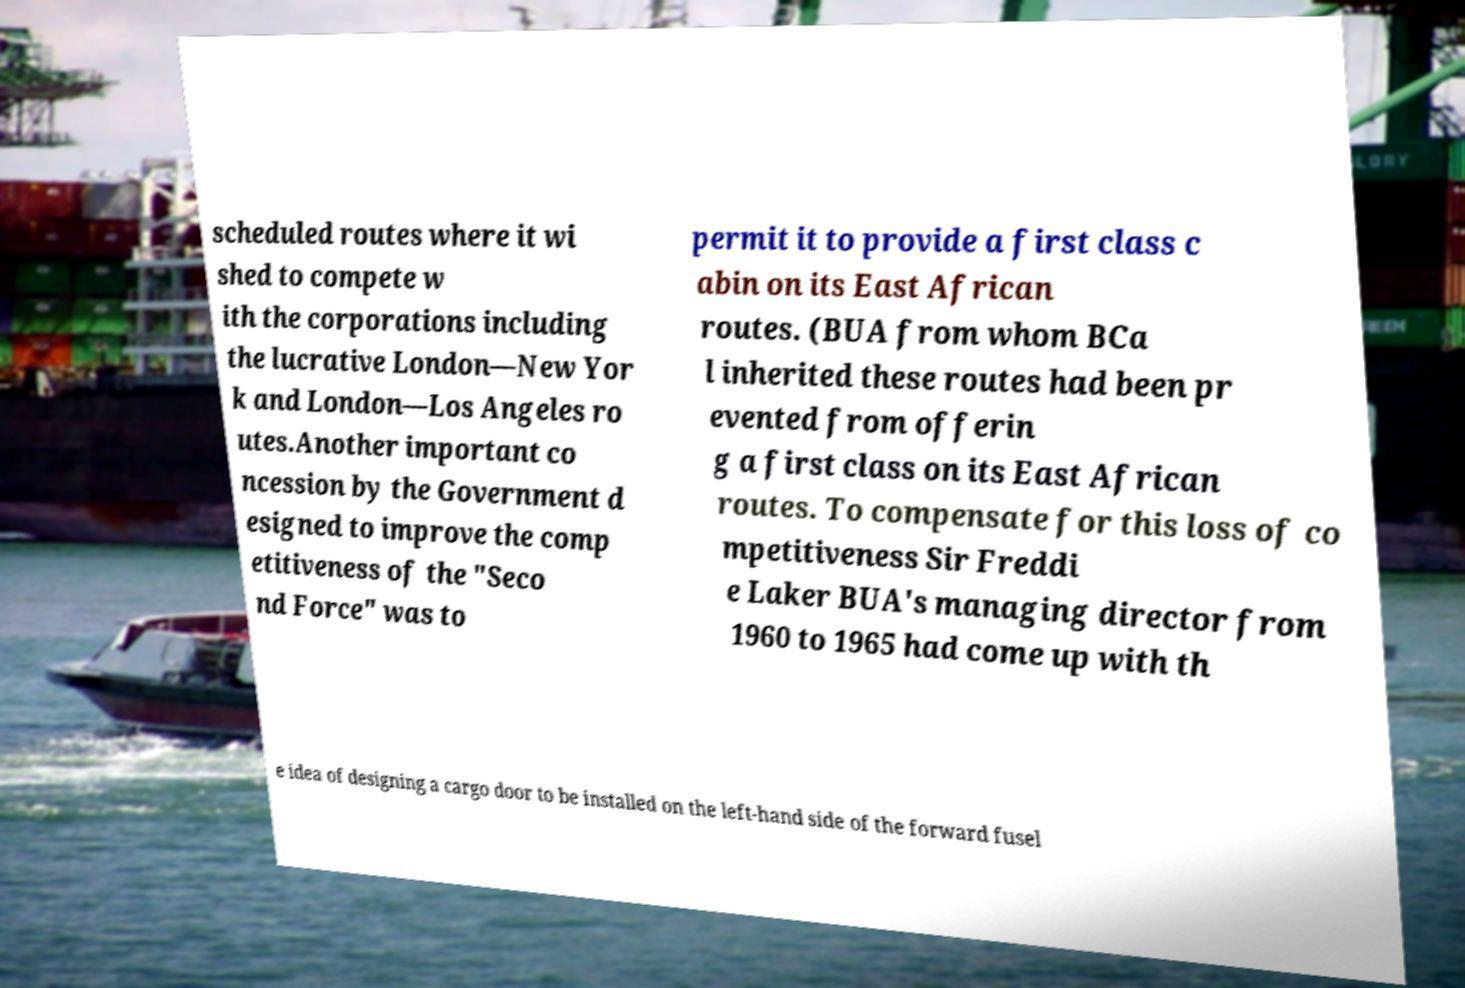Could you assist in decoding the text presented in this image and type it out clearly? scheduled routes where it wi shed to compete w ith the corporations including the lucrative London—New Yor k and London—Los Angeles ro utes.Another important co ncession by the Government d esigned to improve the comp etitiveness of the "Seco nd Force" was to permit it to provide a first class c abin on its East African routes. (BUA from whom BCa l inherited these routes had been pr evented from offerin g a first class on its East African routes. To compensate for this loss of co mpetitiveness Sir Freddi e Laker BUA's managing director from 1960 to 1965 had come up with th e idea of designing a cargo door to be installed on the left-hand side of the forward fusel 